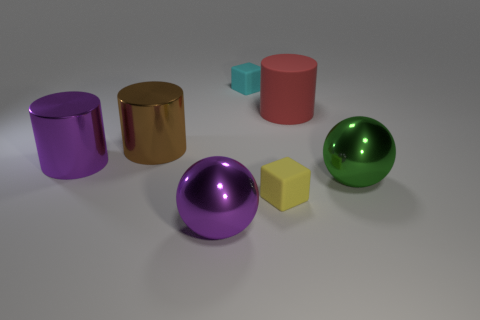Is there a pattern to the arrangement of the objects? There doesn't seem to be a deliberate pattern; however, the objects are arranged with similar shapes grouped together – the cylinders on the left and the cubes towards the center.  How do the objects' textures contribute to the overall feel of the scene? The varying textures, from matte to reflective finishes, create a contrast that gives the scene visual interest and depth.  Does the lighting affect the appearance of the objects' colors? Yes, the lighting highlights the colors vibrancy and brings out the glossiness of the reflective objects while showing the solid colors of the matte objects. 